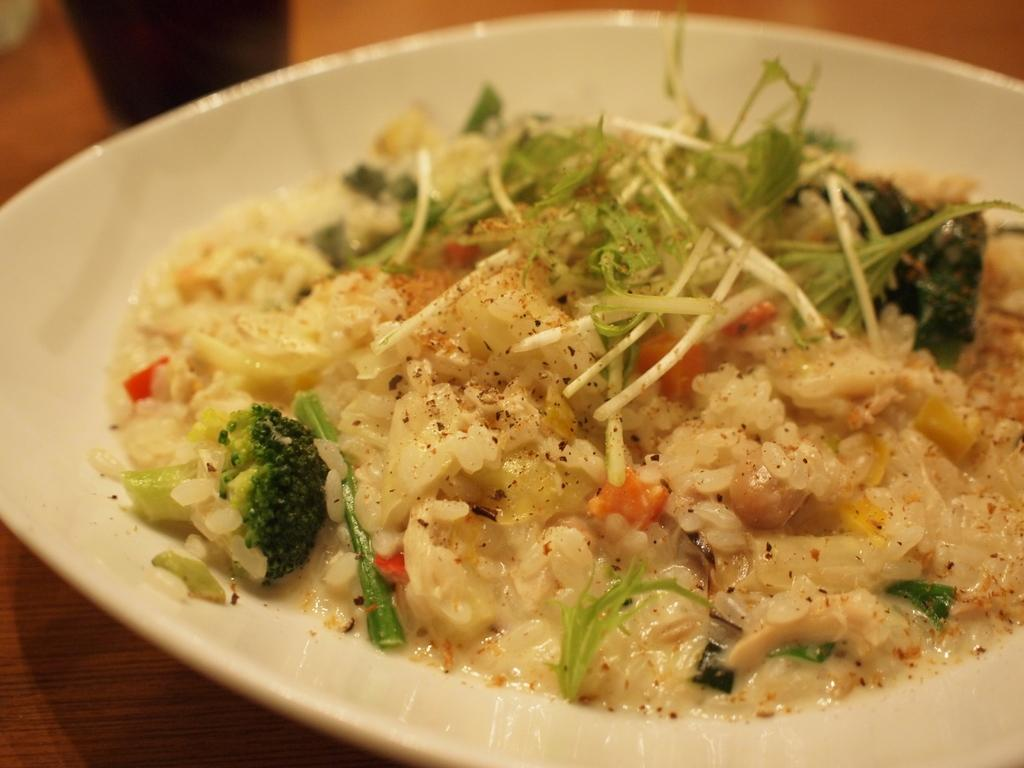What is the main subject in the foreground of the image? There is food served in a plate in the foreground of the image. What can be seen in the background of the image? There is a table in the image. What type of skirt is hanging from the ceiling in the image? There is no skirt present in the image; it only features food served in a plate and a table. 